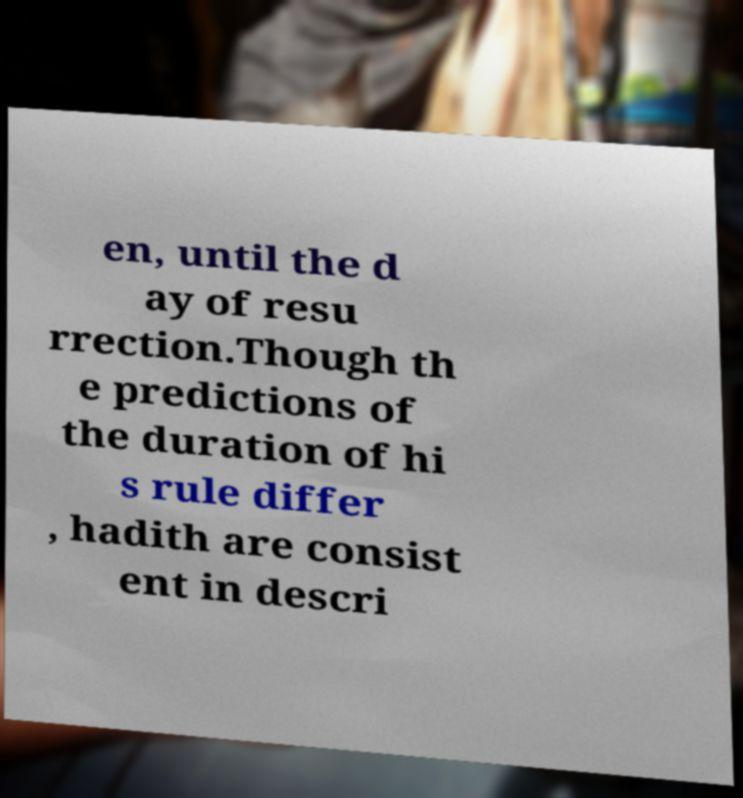There's text embedded in this image that I need extracted. Can you transcribe it verbatim? en, until the d ay of resu rrection.Though th e predictions of the duration of hi s rule differ , hadith are consist ent in descri 